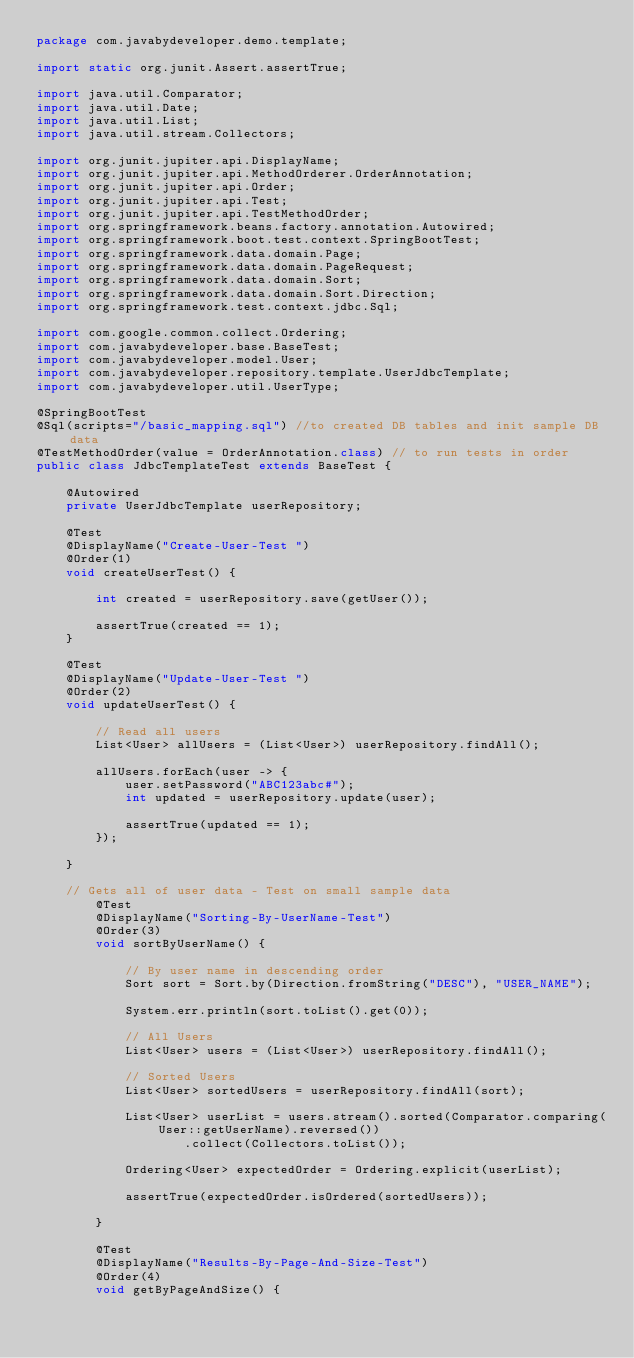<code> <loc_0><loc_0><loc_500><loc_500><_Java_>package com.javabydeveloper.demo.template;

import static org.junit.Assert.assertTrue;

import java.util.Comparator;
import java.util.Date;
import java.util.List;
import java.util.stream.Collectors;

import org.junit.jupiter.api.DisplayName;
import org.junit.jupiter.api.MethodOrderer.OrderAnnotation;
import org.junit.jupiter.api.Order;
import org.junit.jupiter.api.Test;
import org.junit.jupiter.api.TestMethodOrder;
import org.springframework.beans.factory.annotation.Autowired;
import org.springframework.boot.test.context.SpringBootTest;
import org.springframework.data.domain.Page;
import org.springframework.data.domain.PageRequest;
import org.springframework.data.domain.Sort;
import org.springframework.data.domain.Sort.Direction;
import org.springframework.test.context.jdbc.Sql;

import com.google.common.collect.Ordering;
import com.javabydeveloper.base.BaseTest;
import com.javabydeveloper.model.User;
import com.javabydeveloper.repository.template.UserJdbcTemplate;
import com.javabydeveloper.util.UserType;

@SpringBootTest
@Sql(scripts="/basic_mapping.sql") //to created DB tables and init sample DB data
@TestMethodOrder(value = OrderAnnotation.class) // to run tests in order
public class JdbcTemplateTest extends BaseTest {

	@Autowired
	private UserJdbcTemplate userRepository;
	
	@Test
	@DisplayName("Create-User-Test ")
	@Order(1)
	void createUserTest() {
		
		int created = userRepository.save(getUser());
		
		assertTrue(created == 1);
	}
	
	@Test
	@DisplayName("Update-User-Test ")
	@Order(2)
	void updateUserTest() {
		
		// Read all users
		List<User> allUsers = (List<User>) userRepository.findAll();
		
		allUsers.forEach(user -> {
			user.setPassword("ABC123abc#");
			int updated = userRepository.update(user);
			
			assertTrue(updated == 1);
		});
		
	}
	
	// Gets all of user data - Test on small sample data
		@Test
		@DisplayName("Sorting-By-UserName-Test")
		@Order(3)
		void sortByUserName() {

			// By user name in descending order
			Sort sort = Sort.by(Direction.fromString("DESC"), "USER_NAME");
			
			System.err.println(sort.toList().get(0));

			// All Users
			List<User> users = (List<User>) userRepository.findAll();

			// Sorted Users
			List<User> sortedUsers = userRepository.findAll(sort);

			List<User> userList = users.stream().sorted(Comparator.comparing(User::getUserName).reversed())
					.collect(Collectors.toList());

			Ordering<User> expectedOrder = Ordering.explicit(userList);

			assertTrue(expectedOrder.isOrdered(sortedUsers));

		}

		@Test
		@DisplayName("Results-By-Page-And-Size-Test")
		@Order(4)
		void getByPageAndSize() {
</code> 